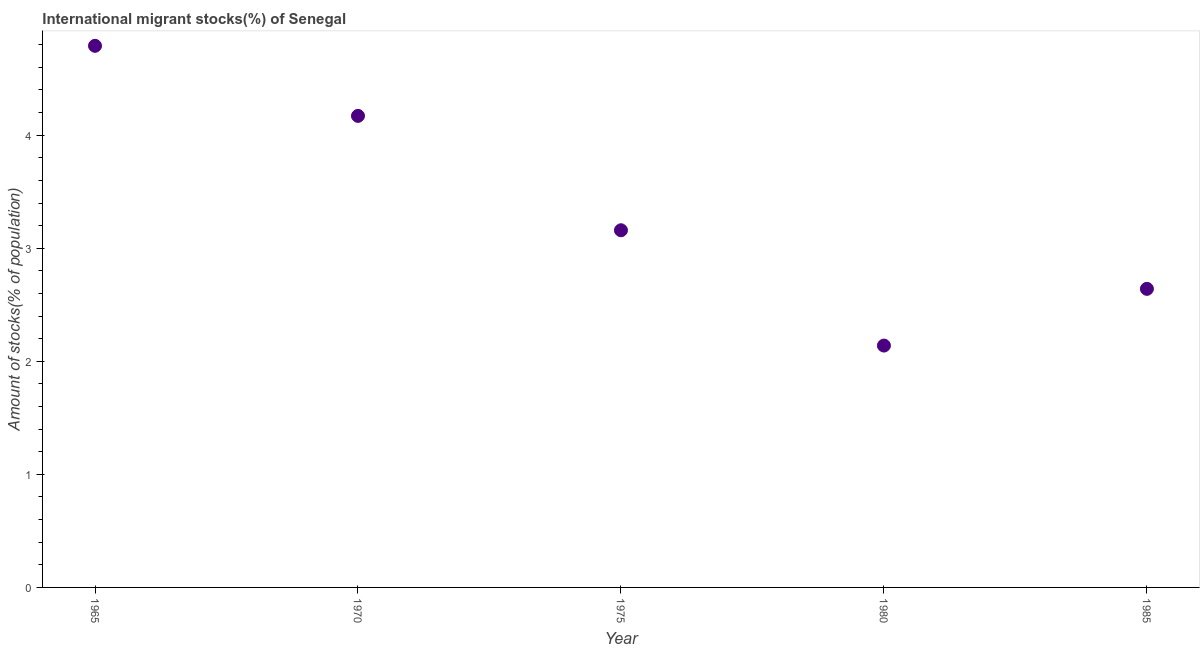What is the number of international migrant stocks in 1980?
Offer a terse response. 2.14. Across all years, what is the maximum number of international migrant stocks?
Make the answer very short. 4.79. Across all years, what is the minimum number of international migrant stocks?
Provide a short and direct response. 2.14. In which year was the number of international migrant stocks maximum?
Provide a short and direct response. 1965. What is the sum of the number of international migrant stocks?
Provide a short and direct response. 16.9. What is the difference between the number of international migrant stocks in 1965 and 1980?
Your response must be concise. 2.65. What is the average number of international migrant stocks per year?
Give a very brief answer. 3.38. What is the median number of international migrant stocks?
Offer a very short reply. 3.16. What is the ratio of the number of international migrant stocks in 1975 to that in 1985?
Your answer should be compact. 1.2. What is the difference between the highest and the second highest number of international migrant stocks?
Ensure brevity in your answer.  0.62. Is the sum of the number of international migrant stocks in 1965 and 1980 greater than the maximum number of international migrant stocks across all years?
Offer a very short reply. Yes. What is the difference between the highest and the lowest number of international migrant stocks?
Keep it short and to the point. 2.65. How many years are there in the graph?
Your answer should be very brief. 5. What is the difference between two consecutive major ticks on the Y-axis?
Your answer should be compact. 1. Does the graph contain grids?
Keep it short and to the point. No. What is the title of the graph?
Your response must be concise. International migrant stocks(%) of Senegal. What is the label or title of the Y-axis?
Ensure brevity in your answer.  Amount of stocks(% of population). What is the Amount of stocks(% of population) in 1965?
Make the answer very short. 4.79. What is the Amount of stocks(% of population) in 1970?
Offer a terse response. 4.17. What is the Amount of stocks(% of population) in 1975?
Your answer should be compact. 3.16. What is the Amount of stocks(% of population) in 1980?
Offer a very short reply. 2.14. What is the Amount of stocks(% of population) in 1985?
Your answer should be compact. 2.64. What is the difference between the Amount of stocks(% of population) in 1965 and 1970?
Offer a terse response. 0.62. What is the difference between the Amount of stocks(% of population) in 1965 and 1975?
Make the answer very short. 1.63. What is the difference between the Amount of stocks(% of population) in 1965 and 1980?
Your answer should be compact. 2.65. What is the difference between the Amount of stocks(% of population) in 1965 and 1985?
Provide a succinct answer. 2.15. What is the difference between the Amount of stocks(% of population) in 1970 and 1975?
Your answer should be very brief. 1.01. What is the difference between the Amount of stocks(% of population) in 1970 and 1980?
Provide a short and direct response. 2.03. What is the difference between the Amount of stocks(% of population) in 1970 and 1985?
Offer a terse response. 1.53. What is the difference between the Amount of stocks(% of population) in 1975 and 1980?
Give a very brief answer. 1.02. What is the difference between the Amount of stocks(% of population) in 1975 and 1985?
Make the answer very short. 0.52. What is the difference between the Amount of stocks(% of population) in 1980 and 1985?
Make the answer very short. -0.5. What is the ratio of the Amount of stocks(% of population) in 1965 to that in 1970?
Ensure brevity in your answer.  1.15. What is the ratio of the Amount of stocks(% of population) in 1965 to that in 1975?
Provide a succinct answer. 1.52. What is the ratio of the Amount of stocks(% of population) in 1965 to that in 1980?
Provide a short and direct response. 2.24. What is the ratio of the Amount of stocks(% of population) in 1965 to that in 1985?
Provide a succinct answer. 1.81. What is the ratio of the Amount of stocks(% of population) in 1970 to that in 1975?
Make the answer very short. 1.32. What is the ratio of the Amount of stocks(% of population) in 1970 to that in 1980?
Offer a very short reply. 1.95. What is the ratio of the Amount of stocks(% of population) in 1970 to that in 1985?
Your answer should be very brief. 1.58. What is the ratio of the Amount of stocks(% of population) in 1975 to that in 1980?
Provide a short and direct response. 1.48. What is the ratio of the Amount of stocks(% of population) in 1975 to that in 1985?
Ensure brevity in your answer.  1.2. What is the ratio of the Amount of stocks(% of population) in 1980 to that in 1985?
Provide a short and direct response. 0.81. 